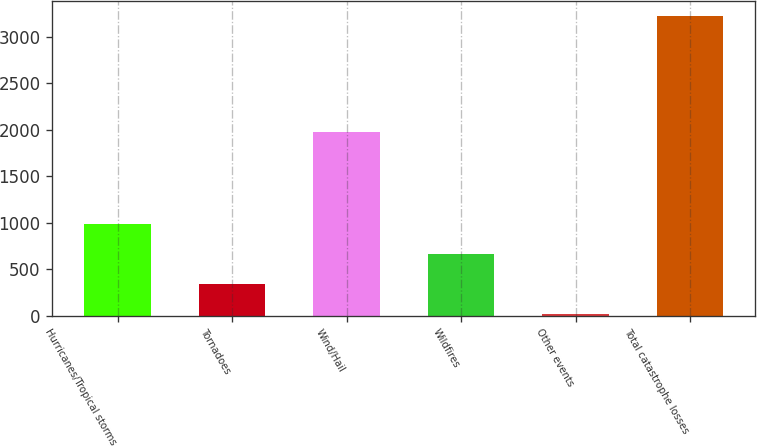<chart> <loc_0><loc_0><loc_500><loc_500><bar_chart><fcel>Hurricanes/Tropical storms<fcel>Tornadoes<fcel>Wind/Hail<fcel>Wildfires<fcel>Other events<fcel>Total catastrophe losses<nl><fcel>985.2<fcel>344.4<fcel>1973<fcel>664.8<fcel>24<fcel>3228<nl></chart> 